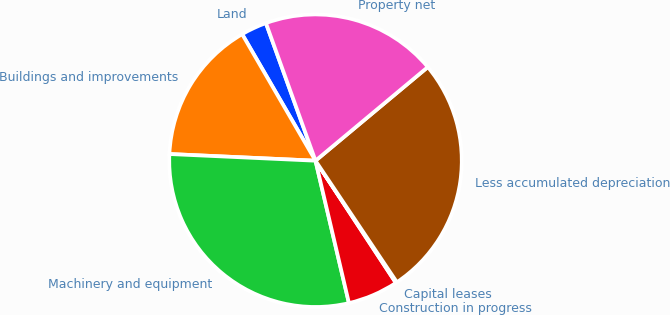Convert chart. <chart><loc_0><loc_0><loc_500><loc_500><pie_chart><fcel>Land<fcel>Buildings and improvements<fcel>Machinery and equipment<fcel>Construction in progress<fcel>Capital leases<fcel>Less accumulated depreciation<fcel>Property net<nl><fcel>2.86%<fcel>15.91%<fcel>29.4%<fcel>5.59%<fcel>0.13%<fcel>26.67%<fcel>19.44%<nl></chart> 